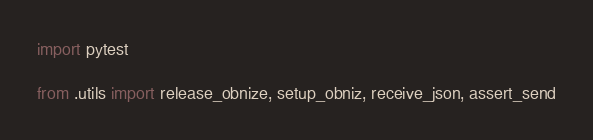<code> <loc_0><loc_0><loc_500><loc_500><_Python_>import pytest

from .utils import release_obnize, setup_obniz, receive_json, assert_send

</code> 